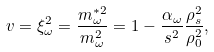<formula> <loc_0><loc_0><loc_500><loc_500>v = \xi _ { \omega } ^ { 2 } = \frac { m _ { \omega } ^ { * 2 } } { m _ { \omega } ^ { 2 } } = 1 - \frac { \alpha _ { \omega } } { s ^ { 2 } } \frac { \rho _ { s } ^ { 2 } } { \rho _ { 0 } ^ { 2 } } ,</formula> 